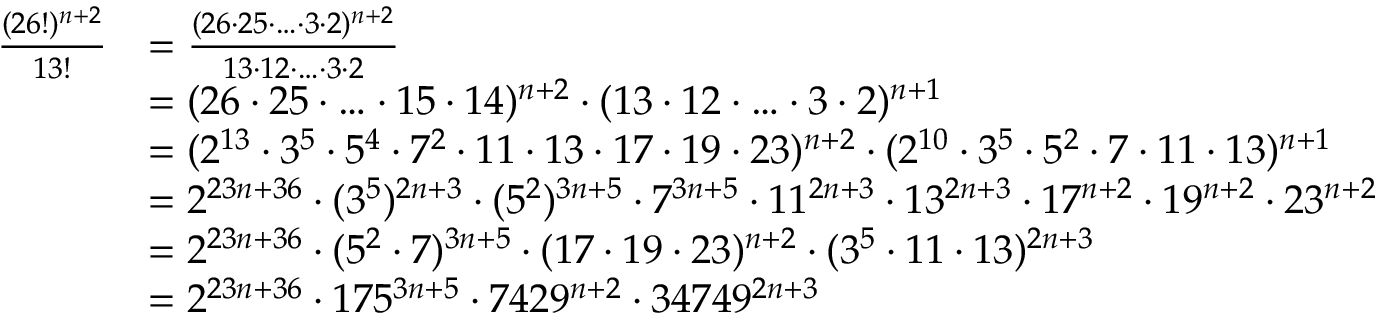Convert formula to latex. <formula><loc_0><loc_0><loc_500><loc_500>\begin{array} { r l } { \frac { ( 2 6 ! ) ^ { n + 2 } } { 1 3 ! } } & { = \frac { ( 2 6 \cdot 2 5 \cdot \dots \cdot 3 \cdot 2 ) ^ { n + 2 } } { 1 3 \cdot 1 2 \cdot \dots \cdot 3 \cdot 2 } } \\ & { = ( 2 6 \cdot 2 5 \cdot \dots \cdot 1 5 \cdot 1 4 ) ^ { n + 2 } \cdot ( 1 3 \cdot 1 2 \cdot \dots \cdot 3 \cdot 2 ) ^ { n + 1 } } \\ & { = ( 2 ^ { 1 3 } \cdot 3 ^ { 5 } \cdot 5 ^ { 4 } \cdot 7 ^ { 2 } \cdot 1 1 \cdot 1 3 \cdot 1 7 \cdot 1 9 \cdot 2 3 ) ^ { n + 2 } \cdot ( 2 ^ { 1 0 } \cdot 3 ^ { 5 } \cdot 5 ^ { 2 } \cdot 7 \cdot 1 1 \cdot 1 3 ) ^ { n + 1 } } \\ & { = 2 ^ { 2 3 n + 3 6 } \cdot ( 3 ^ { 5 } ) ^ { 2 n + 3 } \cdot ( 5 ^ { 2 } ) ^ { 3 n + 5 } \cdot 7 ^ { 3 n + 5 } \cdot 1 1 ^ { 2 n + 3 } \cdot 1 3 ^ { 2 n + 3 } \cdot 1 7 ^ { n + 2 } \cdot 1 9 ^ { n + 2 } \cdot 2 3 ^ { n + 2 } } \\ & { = 2 ^ { 2 3 n + 3 6 } \cdot ( 5 ^ { 2 } \cdot 7 ) ^ { 3 n + 5 } \cdot ( 1 7 \cdot 1 9 \cdot 2 3 ) ^ { n + 2 } \cdot ( 3 ^ { 5 } \cdot 1 1 \cdot 1 3 ) ^ { 2 n + 3 } } \\ & { = 2 ^ { 2 3 n + 3 6 } \cdot 1 7 5 ^ { 3 n + 5 } \cdot 7 4 2 9 ^ { n + 2 } \cdot 3 4 7 4 9 ^ { 2 n + 3 } } \end{array}</formula> 